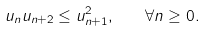<formula> <loc_0><loc_0><loc_500><loc_500>u _ { n } u _ { n + 2 } \leq u _ { n + 1 } ^ { 2 } , \quad \forall n \geq 0 .</formula> 